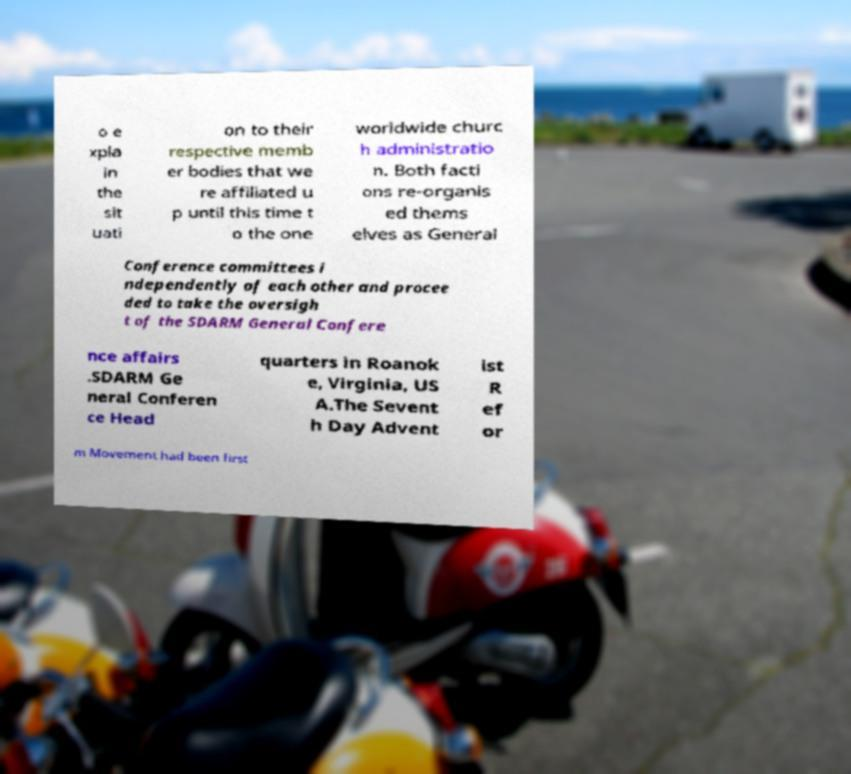Please identify and transcribe the text found in this image. o e xpla in the sit uati on to their respective memb er bodies that we re affiliated u p until this time t o the one worldwide churc h administratio n. Both facti ons re-organis ed thems elves as General Conference committees i ndependently of each other and procee ded to take the oversigh t of the SDARM General Confere nce affairs .SDARM Ge neral Conferen ce Head quarters in Roanok e, Virginia, US A.The Sevent h Day Advent ist R ef or m Movement had been first 